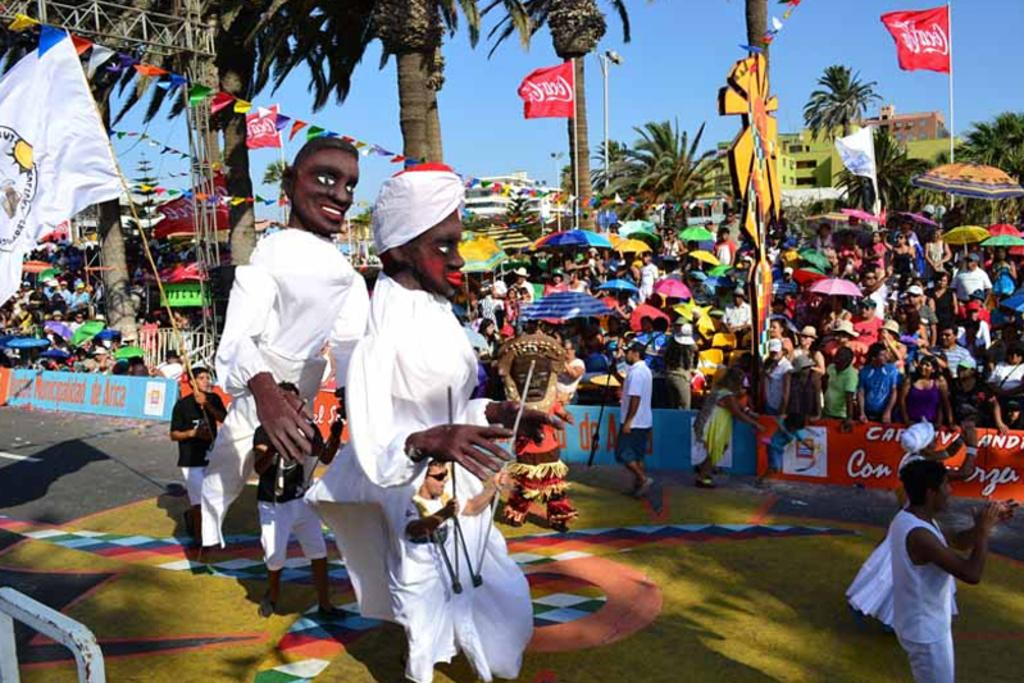<image>
Give a short and clear explanation of the subsequent image. Some of the sponsors for this event is Coca cola. 